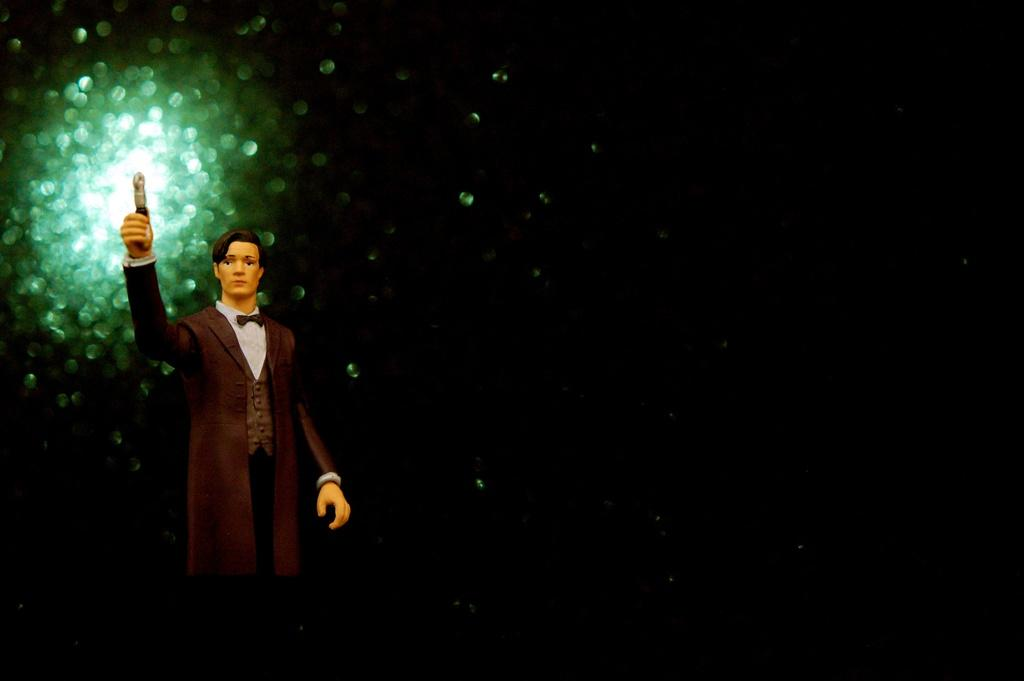What is the main subject of the image? There is a man in the image. What is the man doing in the image? The man is holding an object and standing. What can be seen in the background of the image? The background of the image is black. Are there any other objects or structures visible in the image? Yes, there are light poles in the image. What type of current can be seen flowing through the man's elbow in the image? There is no current flowing through the man's elbow in the image, as the image does not depict any electrical currents or similar phenomena. 